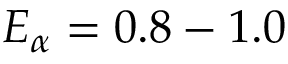Convert formula to latex. <formula><loc_0><loc_0><loc_500><loc_500>E _ { \alpha } = 0 . 8 - 1 . 0</formula> 